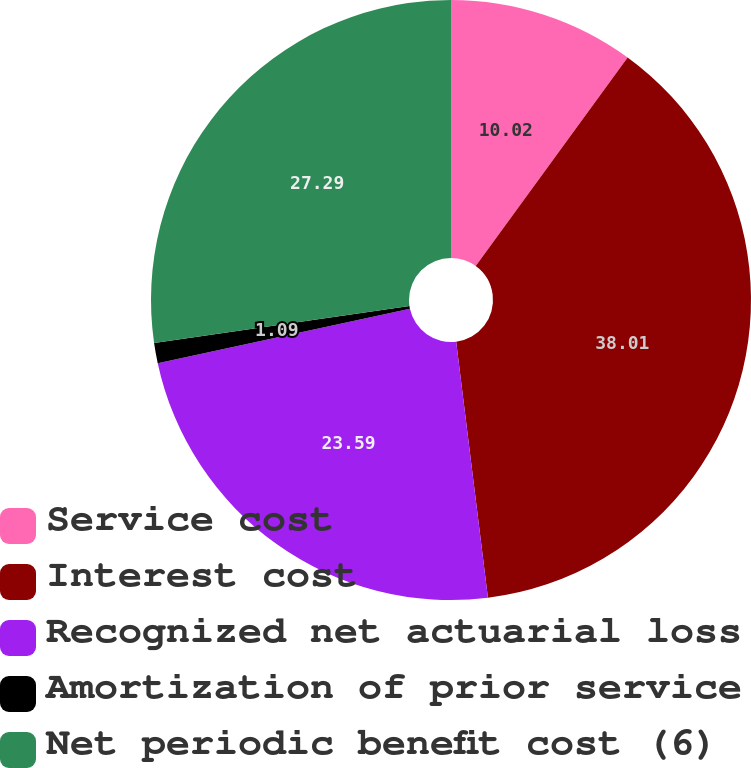Convert chart to OTSL. <chart><loc_0><loc_0><loc_500><loc_500><pie_chart><fcel>Service cost<fcel>Interest cost<fcel>Recognized net actuarial loss<fcel>Amortization of prior service<fcel>Net periodic benefit cost (6)<nl><fcel>10.02%<fcel>38.02%<fcel>23.59%<fcel>1.09%<fcel>27.29%<nl></chart> 